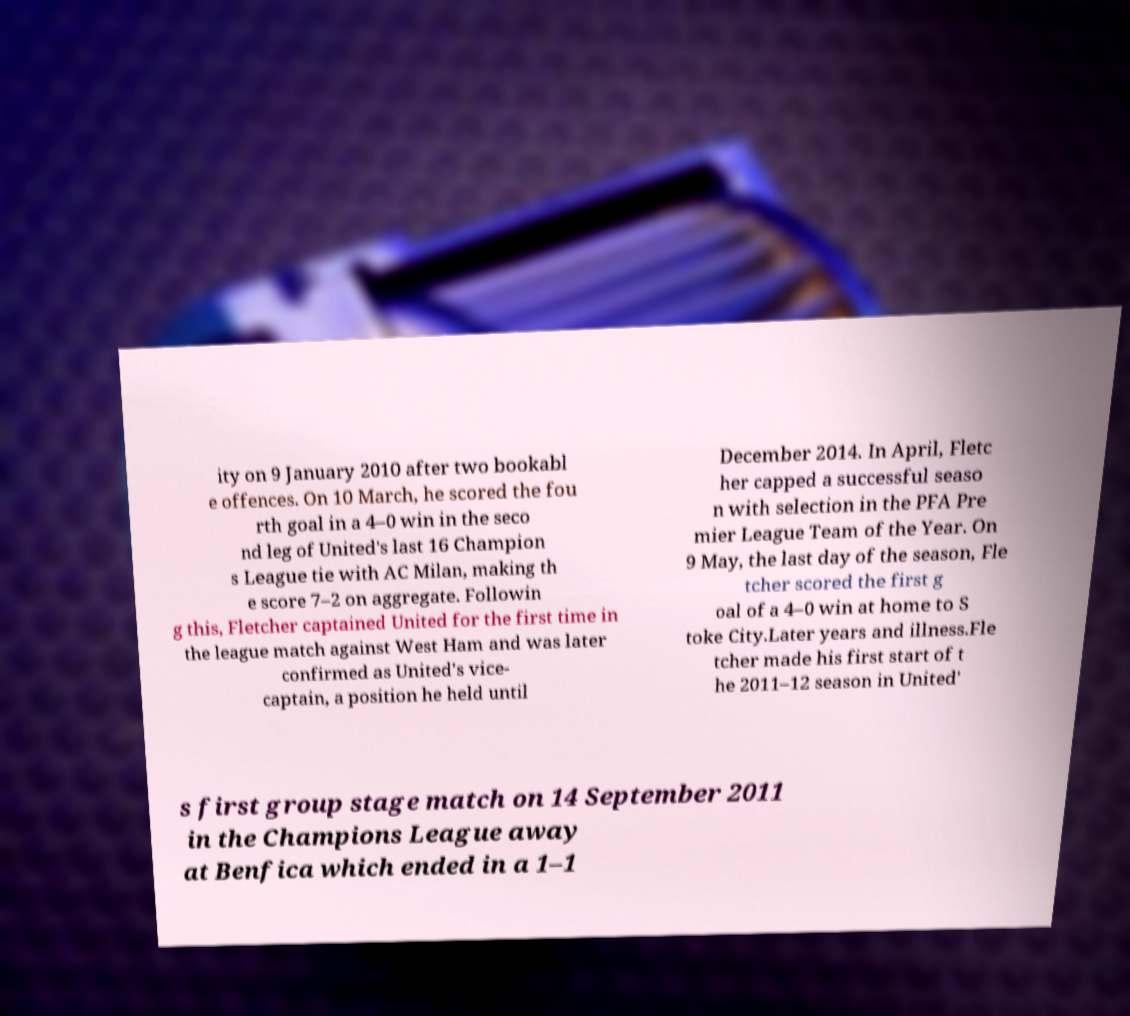Can you accurately transcribe the text from the provided image for me? ity on 9 January 2010 after two bookabl e offences. On 10 March, he scored the fou rth goal in a 4–0 win in the seco nd leg of United's last 16 Champion s League tie with AC Milan, making th e score 7–2 on aggregate. Followin g this, Fletcher captained United for the first time in the league match against West Ham and was later confirmed as United's vice- captain, a position he held until December 2014. In April, Fletc her capped a successful seaso n with selection in the PFA Pre mier League Team of the Year. On 9 May, the last day of the season, Fle tcher scored the first g oal of a 4–0 win at home to S toke City.Later years and illness.Fle tcher made his first start of t he 2011–12 season in United' s first group stage match on 14 September 2011 in the Champions League away at Benfica which ended in a 1–1 